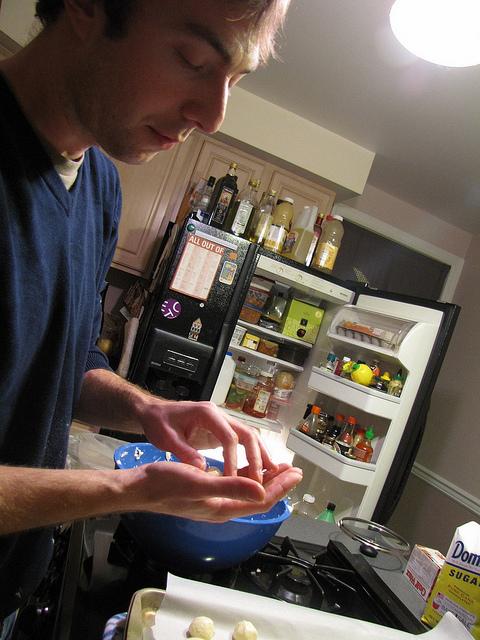What color is the bowl?
Answer briefly. Blue. Is the guy using sugar in the recipe?
Give a very brief answer. Yes. Is there parchment paper on the baking tray?
Write a very short answer. Yes. 